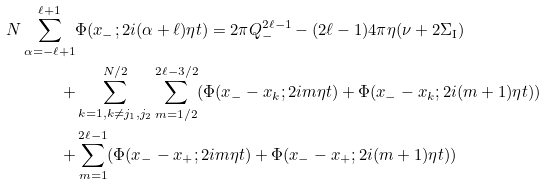Convert formula to latex. <formula><loc_0><loc_0><loc_500><loc_500>N \sum _ { \alpha = - \ell + 1 } ^ { \ell + 1 } & \Phi ( x _ { - } ; 2 i ( \alpha + \ell ) \eta t ) = 2 \pi Q ^ { 2 \ell - 1 } _ { - } - ( 2 \ell - 1 ) 4 \pi \eta ( \nu + 2 \Sigma _ { \text  I})   \\   +&   \sum_{k=1, k\neq j_{1} , j _ { 2 } } ^ { N / 2 } \sum _ { m = 1 / 2 } ^ { 2 \ell - 3 / 2 } ( \Phi ( x _ { - } - x _ { k } ; 2 i m \eta t ) + \Phi ( x _ { - } - x _ { k } ; 2 i ( m + 1 ) \eta t ) ) \\ + & \sum _ { m = 1 } ^ { 2 \ell - 1 } ( \Phi ( x _ { - } - x _ { + } ; 2 i m \eta t ) + \Phi ( x _ { - } - x _ { + } ; 2 i ( m + 1 ) \eta t ) )</formula> 